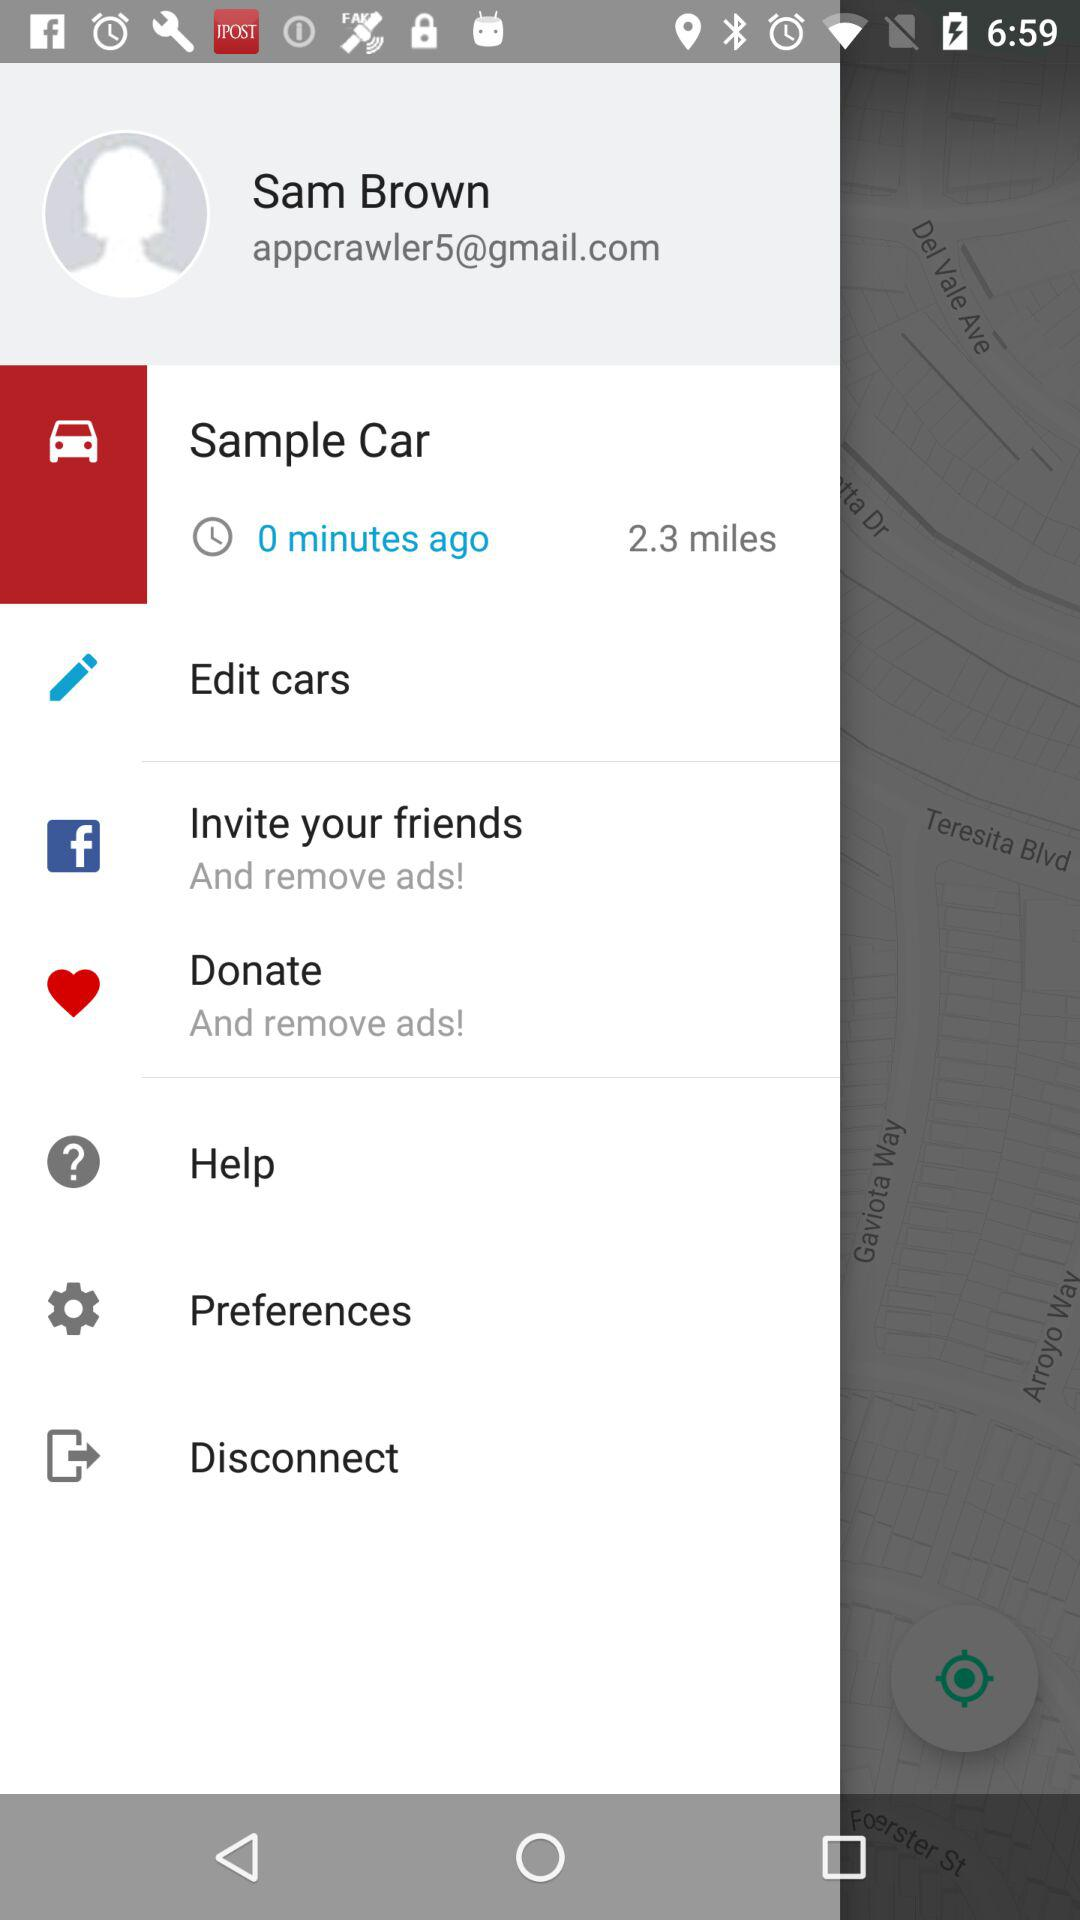What is the name of the user? The name of the user is Sam Brown. 